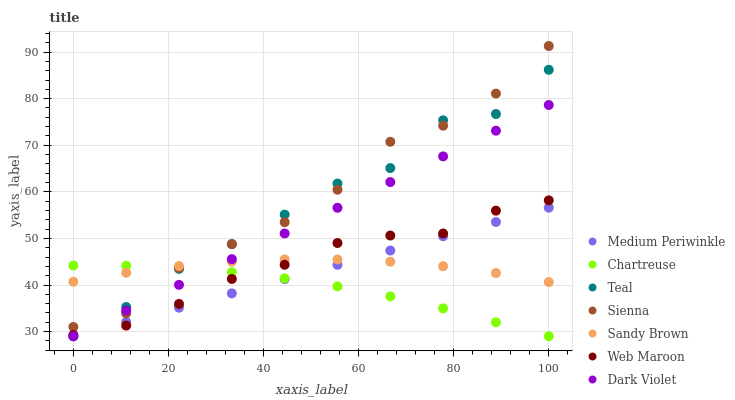Does Chartreuse have the minimum area under the curve?
Answer yes or no. Yes. Does Sienna have the maximum area under the curve?
Answer yes or no. Yes. Does Medium Periwinkle have the minimum area under the curve?
Answer yes or no. No. Does Medium Periwinkle have the maximum area under the curve?
Answer yes or no. No. Is Medium Periwinkle the smoothest?
Answer yes or no. Yes. Is Teal the roughest?
Answer yes or no. Yes. Is Dark Violet the smoothest?
Answer yes or no. No. Is Dark Violet the roughest?
Answer yes or no. No. Does Medium Periwinkle have the lowest value?
Answer yes or no. Yes. Does Sienna have the lowest value?
Answer yes or no. No. Does Sienna have the highest value?
Answer yes or no. Yes. Does Medium Periwinkle have the highest value?
Answer yes or no. No. Is Medium Periwinkle less than Sienna?
Answer yes or no. Yes. Is Sienna greater than Web Maroon?
Answer yes or no. Yes. Does Medium Periwinkle intersect Dark Violet?
Answer yes or no. Yes. Is Medium Periwinkle less than Dark Violet?
Answer yes or no. No. Is Medium Periwinkle greater than Dark Violet?
Answer yes or no. No. Does Medium Periwinkle intersect Sienna?
Answer yes or no. No. 